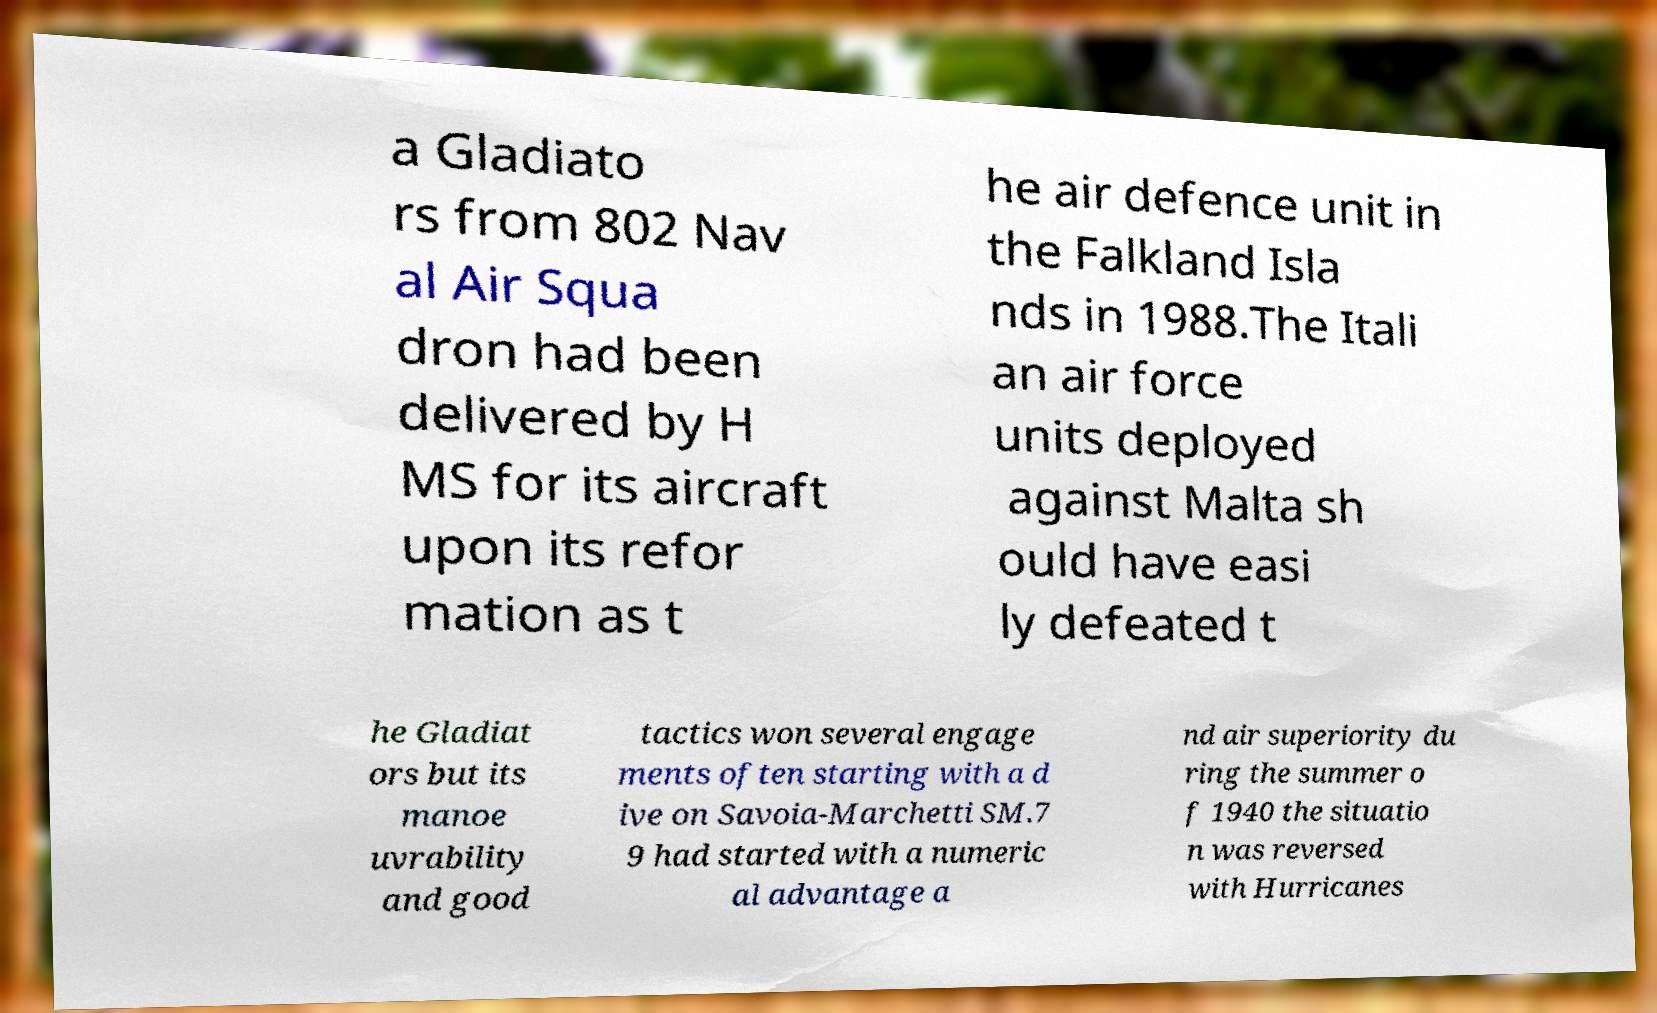Can you accurately transcribe the text from the provided image for me? a Gladiato rs from 802 Nav al Air Squa dron had been delivered by H MS for its aircraft upon its refor mation as t he air defence unit in the Falkland Isla nds in 1988.The Itali an air force units deployed against Malta sh ould have easi ly defeated t he Gladiat ors but its manoe uvrability and good tactics won several engage ments often starting with a d ive on Savoia-Marchetti SM.7 9 had started with a numeric al advantage a nd air superiority du ring the summer o f 1940 the situatio n was reversed with Hurricanes 